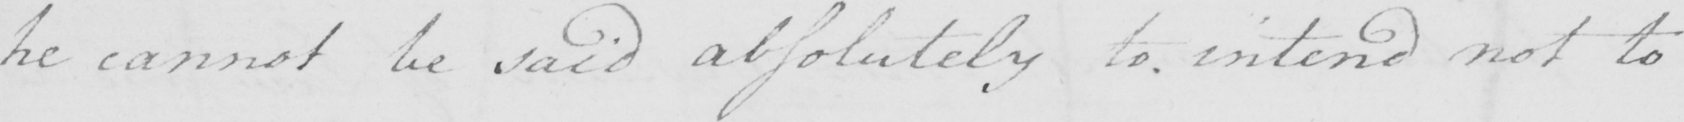Can you read and transcribe this handwriting? he cannot be said absolutely to intend not to 